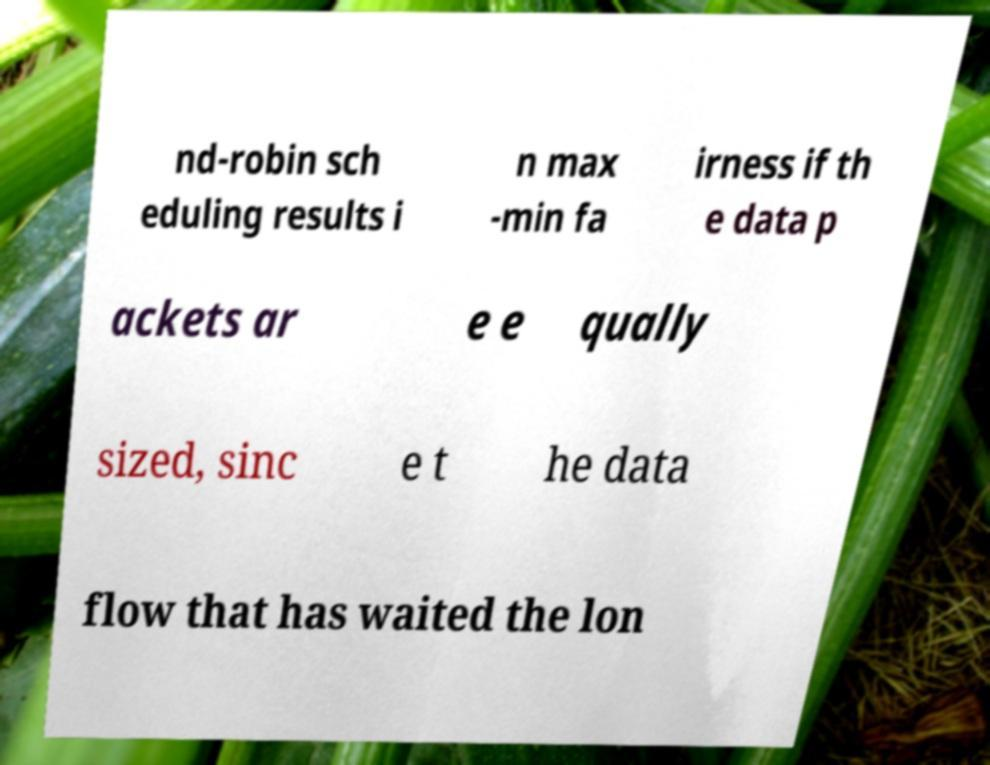Could you extract and type out the text from this image? nd-robin sch eduling results i n max -min fa irness if th e data p ackets ar e e qually sized, sinc e t he data flow that has waited the lon 